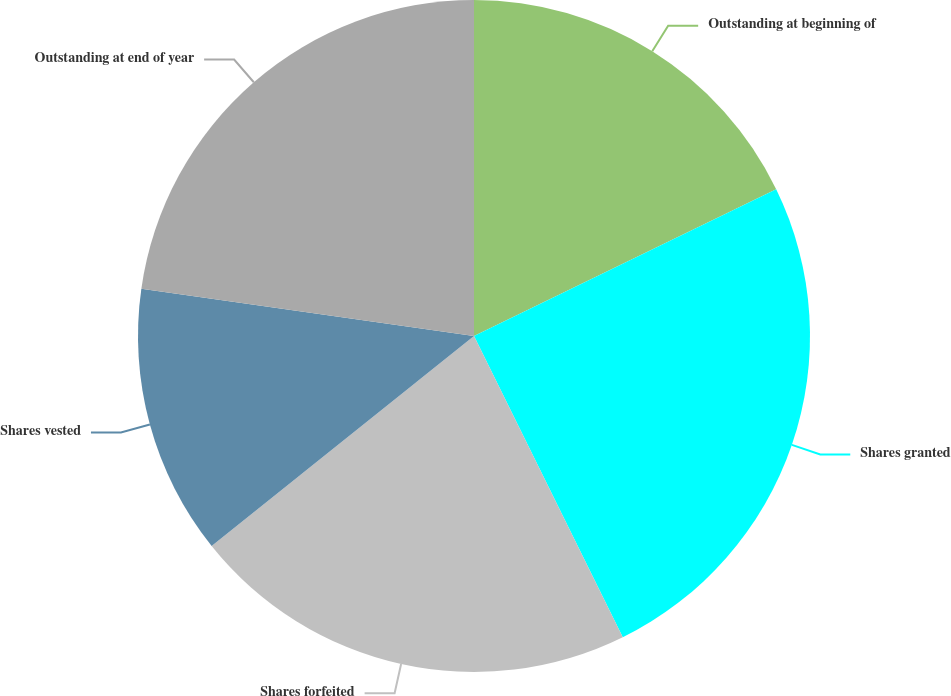Convert chart. <chart><loc_0><loc_0><loc_500><loc_500><pie_chart><fcel>Outstanding at beginning of<fcel>Shares granted<fcel>Shares forfeited<fcel>Shares vested<fcel>Outstanding at end of year<nl><fcel>17.8%<fcel>24.9%<fcel>21.56%<fcel>12.99%<fcel>22.75%<nl></chart> 